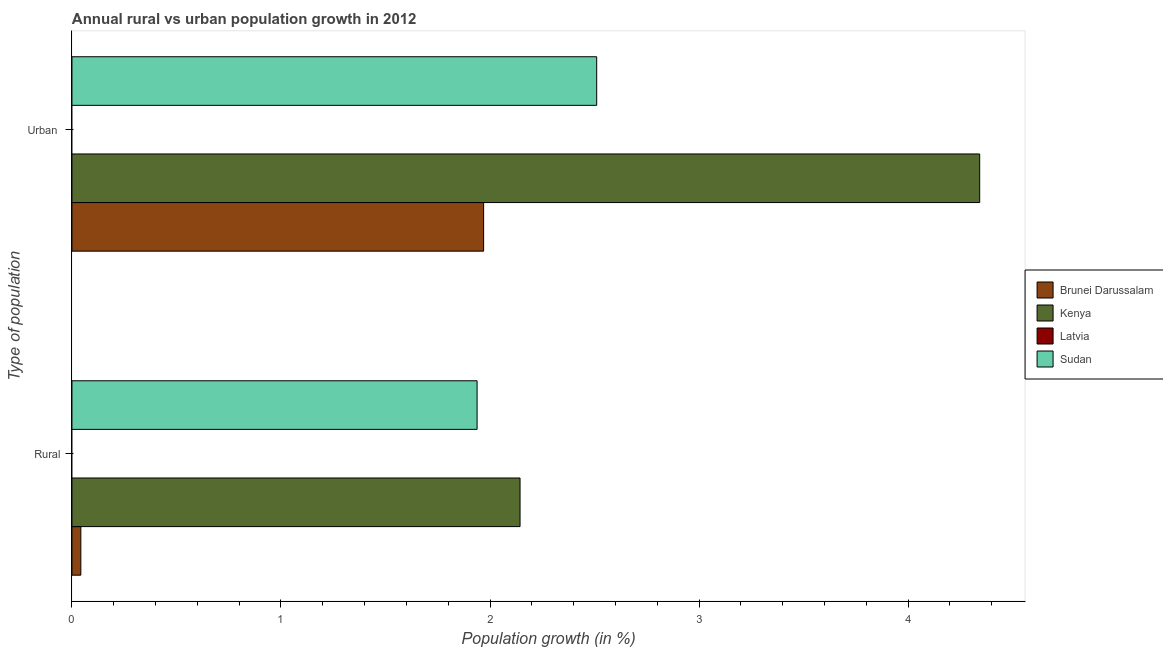How many groups of bars are there?
Provide a short and direct response. 2. Are the number of bars on each tick of the Y-axis equal?
Your response must be concise. Yes. What is the label of the 1st group of bars from the top?
Keep it short and to the point. Urban . What is the rural population growth in Kenya?
Ensure brevity in your answer.  2.14. Across all countries, what is the maximum rural population growth?
Provide a short and direct response. 2.14. Across all countries, what is the minimum rural population growth?
Offer a terse response. 0. In which country was the urban population growth maximum?
Provide a short and direct response. Kenya. What is the total rural population growth in the graph?
Keep it short and to the point. 4.12. What is the difference between the rural population growth in Kenya and that in Sudan?
Keep it short and to the point. 0.21. What is the difference between the rural population growth in Kenya and the urban population growth in Sudan?
Keep it short and to the point. -0.37. What is the average urban population growth per country?
Give a very brief answer. 2.21. What is the difference between the urban population growth and rural population growth in Brunei Darussalam?
Your answer should be compact. 1.93. What is the ratio of the urban population growth in Kenya to that in Sudan?
Your answer should be compact. 1.73. Is the rural population growth in Kenya less than that in Sudan?
Provide a short and direct response. No. In how many countries, is the rural population growth greater than the average rural population growth taken over all countries?
Keep it short and to the point. 2. How many bars are there?
Your answer should be compact. 6. Are all the bars in the graph horizontal?
Ensure brevity in your answer.  Yes. Does the graph contain grids?
Provide a short and direct response. No. How many legend labels are there?
Provide a short and direct response. 4. What is the title of the graph?
Your response must be concise. Annual rural vs urban population growth in 2012. Does "Other small states" appear as one of the legend labels in the graph?
Offer a terse response. No. What is the label or title of the X-axis?
Make the answer very short. Population growth (in %). What is the label or title of the Y-axis?
Give a very brief answer. Type of population. What is the Population growth (in %) in Brunei Darussalam in Rural?
Give a very brief answer. 0.04. What is the Population growth (in %) of Kenya in Rural?
Provide a succinct answer. 2.14. What is the Population growth (in %) of Sudan in Rural?
Your answer should be very brief. 1.94. What is the Population growth (in %) of Brunei Darussalam in Urban ?
Provide a short and direct response. 1.97. What is the Population growth (in %) of Kenya in Urban ?
Offer a terse response. 4.34. What is the Population growth (in %) of Sudan in Urban ?
Offer a terse response. 2.51. Across all Type of population, what is the maximum Population growth (in %) in Brunei Darussalam?
Your answer should be compact. 1.97. Across all Type of population, what is the maximum Population growth (in %) in Kenya?
Make the answer very short. 4.34. Across all Type of population, what is the maximum Population growth (in %) in Sudan?
Give a very brief answer. 2.51. Across all Type of population, what is the minimum Population growth (in %) in Brunei Darussalam?
Your response must be concise. 0.04. Across all Type of population, what is the minimum Population growth (in %) in Kenya?
Offer a very short reply. 2.14. Across all Type of population, what is the minimum Population growth (in %) of Sudan?
Give a very brief answer. 1.94. What is the total Population growth (in %) of Brunei Darussalam in the graph?
Offer a terse response. 2.01. What is the total Population growth (in %) of Kenya in the graph?
Provide a short and direct response. 6.49. What is the total Population growth (in %) in Sudan in the graph?
Provide a short and direct response. 4.45. What is the difference between the Population growth (in %) of Brunei Darussalam in Rural and that in Urban ?
Ensure brevity in your answer.  -1.93. What is the difference between the Population growth (in %) in Kenya in Rural and that in Urban ?
Offer a very short reply. -2.2. What is the difference between the Population growth (in %) of Sudan in Rural and that in Urban ?
Provide a succinct answer. -0.57. What is the difference between the Population growth (in %) in Brunei Darussalam in Rural and the Population growth (in %) in Kenya in Urban ?
Your answer should be compact. -4.3. What is the difference between the Population growth (in %) in Brunei Darussalam in Rural and the Population growth (in %) in Sudan in Urban ?
Keep it short and to the point. -2.47. What is the difference between the Population growth (in %) in Kenya in Rural and the Population growth (in %) in Sudan in Urban ?
Offer a very short reply. -0.37. What is the average Population growth (in %) of Kenya per Type of population?
Your response must be concise. 3.24. What is the average Population growth (in %) in Sudan per Type of population?
Your response must be concise. 2.22. What is the difference between the Population growth (in %) in Brunei Darussalam and Population growth (in %) in Kenya in Rural?
Provide a short and direct response. -2.1. What is the difference between the Population growth (in %) of Brunei Darussalam and Population growth (in %) of Sudan in Rural?
Make the answer very short. -1.9. What is the difference between the Population growth (in %) in Kenya and Population growth (in %) in Sudan in Rural?
Your answer should be very brief. 0.21. What is the difference between the Population growth (in %) in Brunei Darussalam and Population growth (in %) in Kenya in Urban ?
Your response must be concise. -2.37. What is the difference between the Population growth (in %) in Brunei Darussalam and Population growth (in %) in Sudan in Urban ?
Make the answer very short. -0.54. What is the difference between the Population growth (in %) of Kenya and Population growth (in %) of Sudan in Urban ?
Your response must be concise. 1.83. What is the ratio of the Population growth (in %) of Brunei Darussalam in Rural to that in Urban ?
Offer a very short reply. 0.02. What is the ratio of the Population growth (in %) in Kenya in Rural to that in Urban ?
Provide a short and direct response. 0.49. What is the ratio of the Population growth (in %) in Sudan in Rural to that in Urban ?
Offer a terse response. 0.77. What is the difference between the highest and the second highest Population growth (in %) of Brunei Darussalam?
Offer a terse response. 1.93. What is the difference between the highest and the second highest Population growth (in %) in Kenya?
Offer a very short reply. 2.2. What is the difference between the highest and the second highest Population growth (in %) in Sudan?
Make the answer very short. 0.57. What is the difference between the highest and the lowest Population growth (in %) of Brunei Darussalam?
Keep it short and to the point. 1.93. What is the difference between the highest and the lowest Population growth (in %) of Kenya?
Provide a succinct answer. 2.2. What is the difference between the highest and the lowest Population growth (in %) in Sudan?
Ensure brevity in your answer.  0.57. 